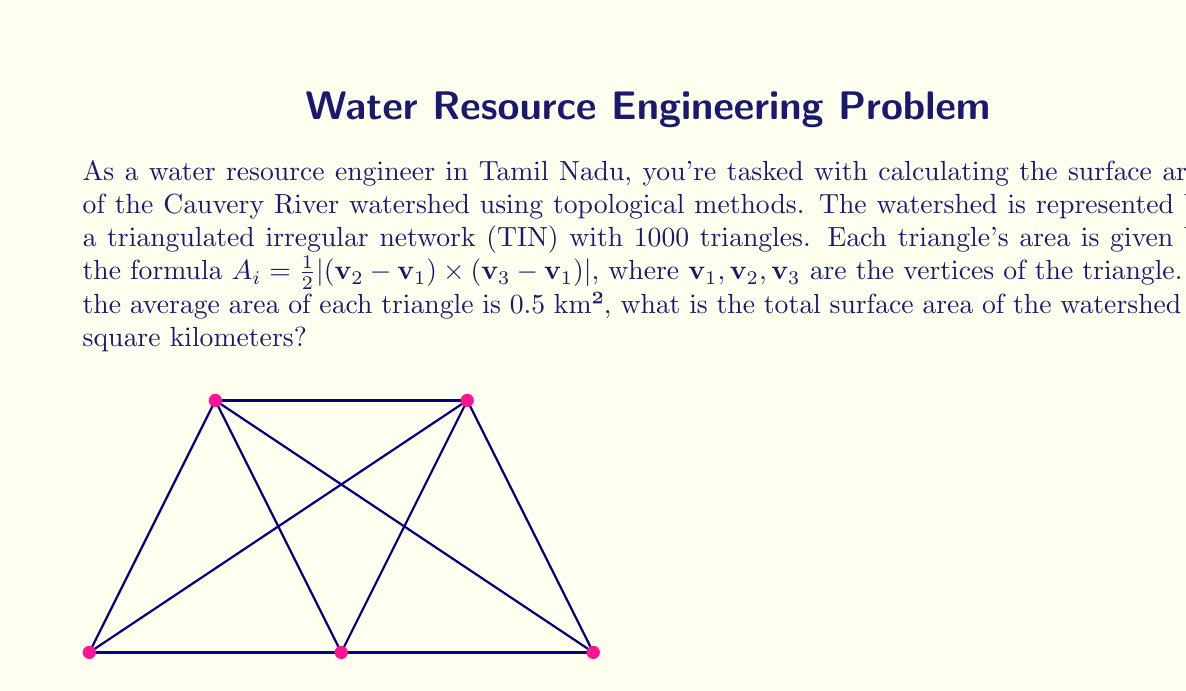Provide a solution to this math problem. To calculate the surface area of the Cauvery River watershed using topological methods, we'll follow these steps:

1) The watershed is represented by a Triangulated Irregular Network (TIN) with 1000 triangles.

2) We're given that the average area of each triangle is 0.5 km².

3) To find the total surface area, we need to sum up the areas of all triangles. In mathematical terms:

   $$A_{total} = \sum_{i=1}^{n} A_i$$

   where $A_{total}$ is the total surface area, $n$ is the number of triangles, and $A_i$ is the area of each individual triangle.

4) Since we know the average area and the number of triangles, we can simplify this to:

   $$A_{total} = n \times A_{average}$$

5) Substituting the values:
   
   $$A_{total} = 1000 \times 0.5\text{ km}^2$$

6) Calculating:

   $$A_{total} = 500\text{ km}^2$$

Therefore, the total surface area of the Cauvery River watershed is 500 square kilometers.
Answer: 500 km² 